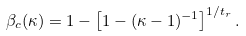Convert formula to latex. <formula><loc_0><loc_0><loc_500><loc_500>\beta _ { c } ( \kappa ) = 1 - \left [ 1 - ( \kappa - 1 ) ^ { - 1 } \right ] ^ { 1 / t _ { r } } .</formula> 